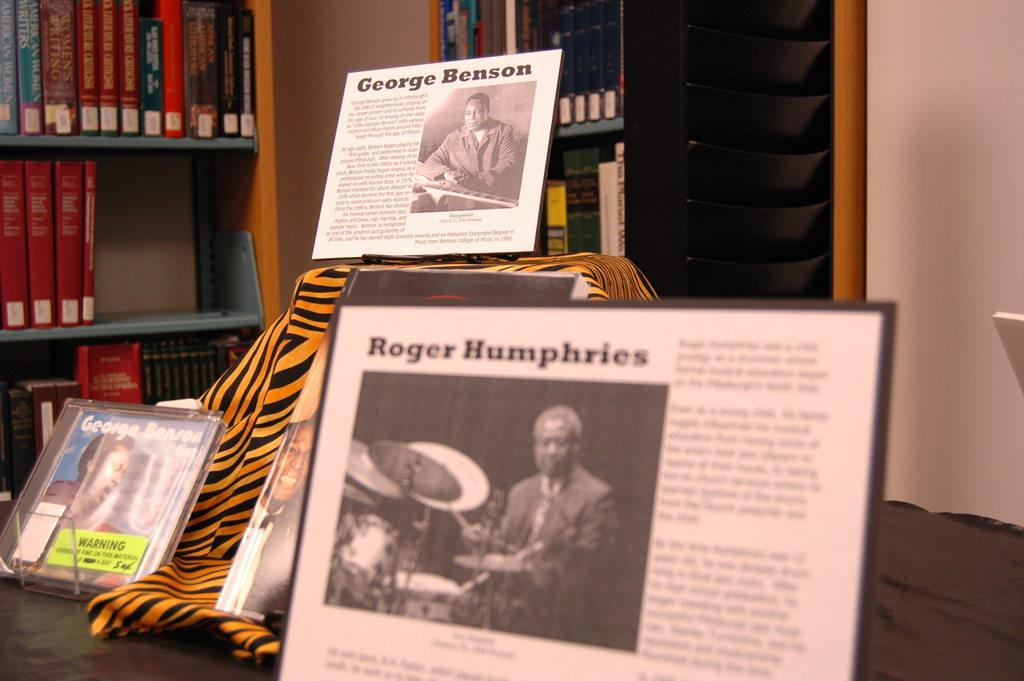What objects are on a platform in the image? There are photo frames on a platform in the image. What type of material is visible in the image? There is a cloth visible in the image. What can be seen in the background of the image? There is a wall and shelves in the background of the image. What items are on the shelves in the image? There are books visible on the shelves in the image. How many balls are visible in the image? There are no balls present in the image. What type of bushes can be seen growing near the wall in the image? There is no mention of bushes in the image; only a wall and shelves are visible in the background. 